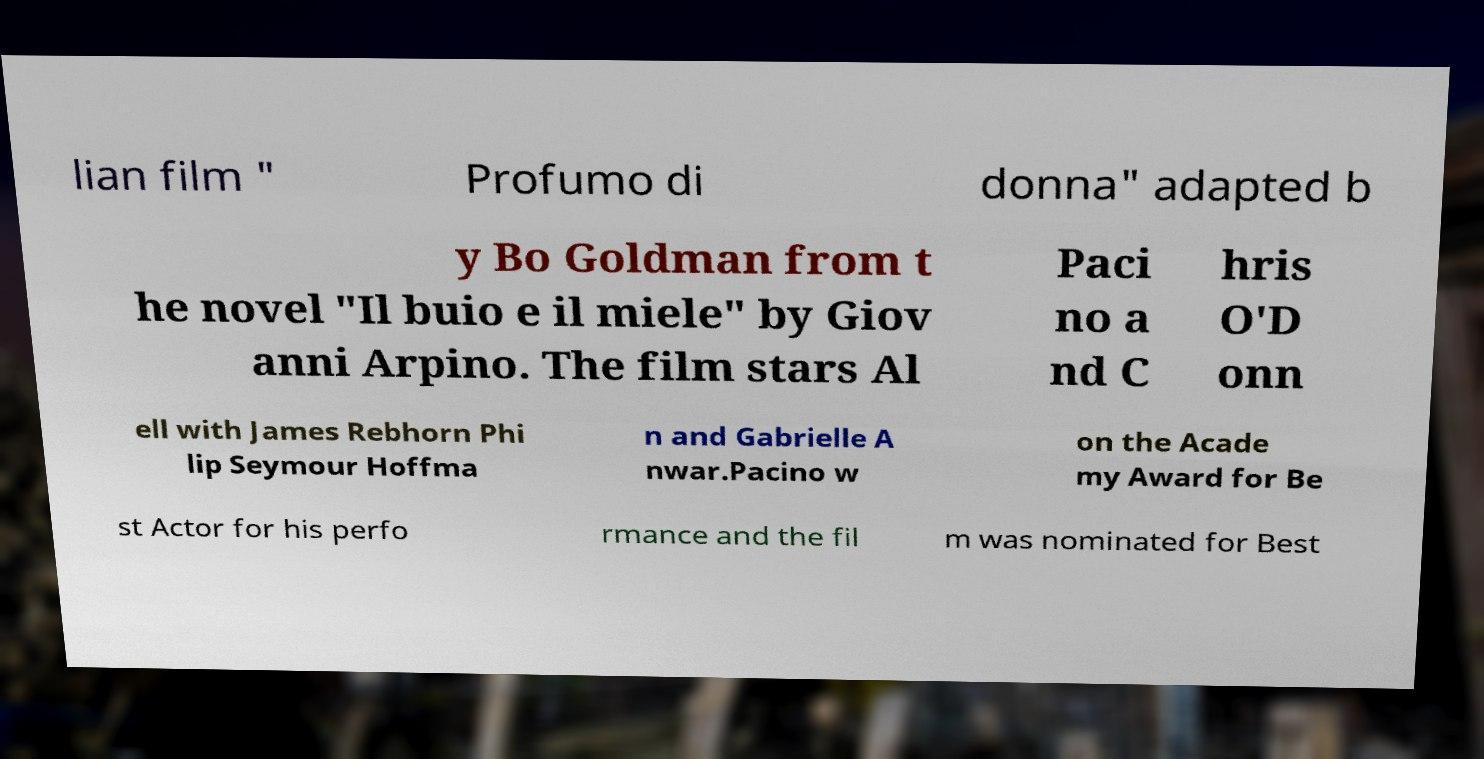Please read and relay the text visible in this image. What does it say? lian film " Profumo di donna" adapted b y Bo Goldman from t he novel "Il buio e il miele" by Giov anni Arpino. The film stars Al Paci no a nd C hris O'D onn ell with James Rebhorn Phi lip Seymour Hoffma n and Gabrielle A nwar.Pacino w on the Acade my Award for Be st Actor for his perfo rmance and the fil m was nominated for Best 